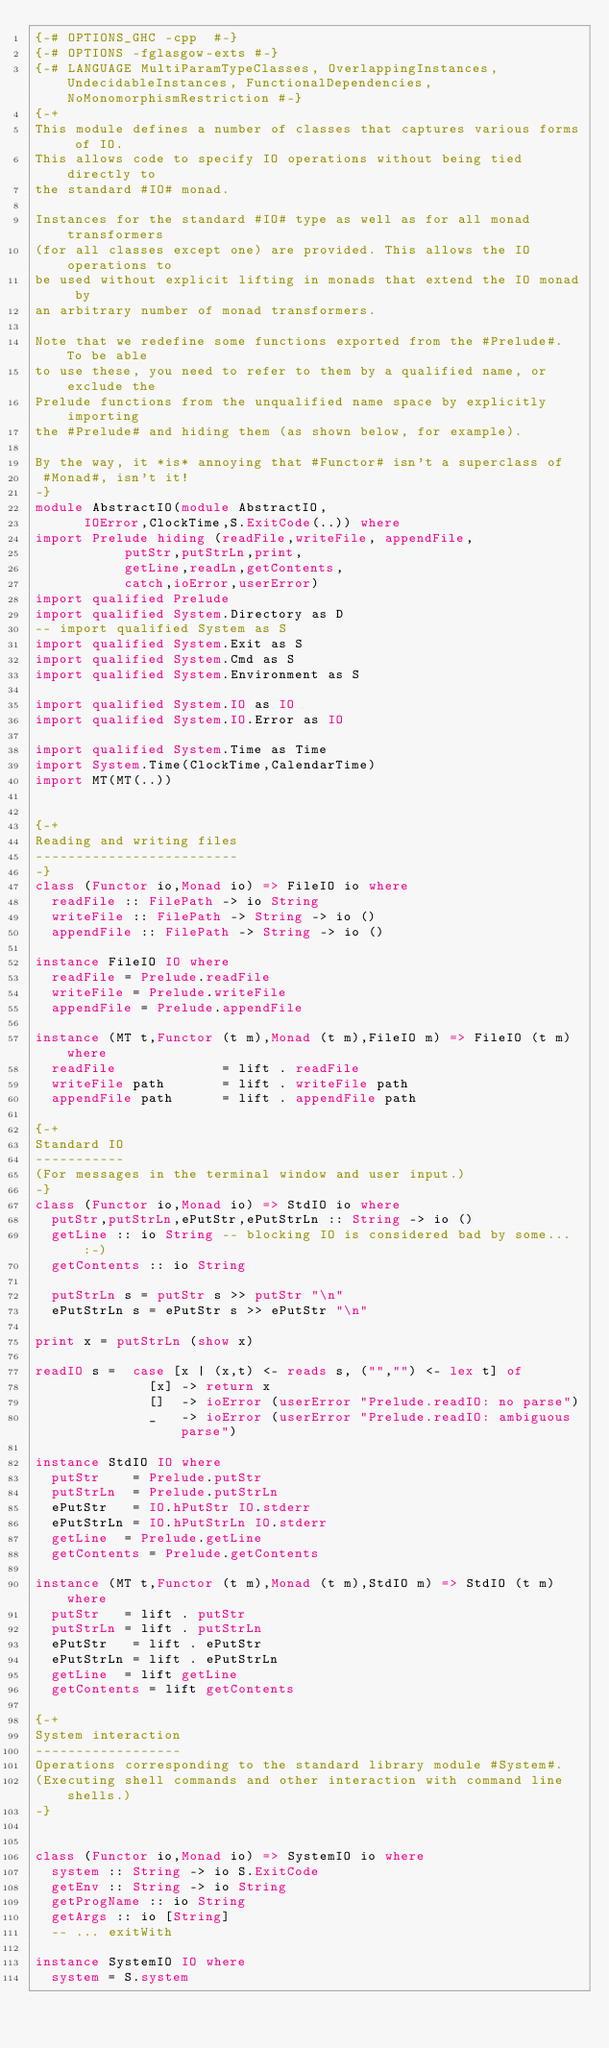<code> <loc_0><loc_0><loc_500><loc_500><_Haskell_>{-# OPTIONS_GHC -cpp  #-}
{-# OPTIONS -fglasgow-exts #-}
{-# LANGUAGE MultiParamTypeClasses, OverlappingInstances, UndecidableInstances, FunctionalDependencies, NoMonomorphismRestriction #-}
{-+
This module defines a number of classes that captures various forms of IO.
This allows code to specify IO operations without being tied directly to
the standard #IO# monad.

Instances for the standard #IO# type as well as for all monad transformers
(for all classes except one) are provided. This allows the IO operations to
be used without explicit lifting in monads that extend the IO monad by
an arbitrary number of monad transformers.

Note that we redefine some functions exported from the #Prelude#. To be able
to use these, you need to refer to them by a qualified name, or exclude the
Prelude functions from the unqualified name space by explicitly importing
the #Prelude# and hiding them (as shown below, for example).

By the way, it *is* annoying that #Functor# isn't a superclass of
 #Monad#, isn't it!
-}
module AbstractIO(module AbstractIO,
		  IOError,ClockTime,S.ExitCode(..)) where
import Prelude hiding (readFile,writeFile, appendFile,
		       putStr,putStrLn,print,
		       getLine,readLn,getContents,
		       catch,ioError,userError)
import qualified Prelude
import qualified System.Directory as D
-- import qualified System as S
import qualified System.Exit as S
import qualified System.Cmd as S
import qualified System.Environment as S

import qualified System.IO as IO
import qualified System.IO.Error as IO

import qualified System.Time as Time
import System.Time(ClockTime,CalendarTime)
import MT(MT(..))


{-+
Reading and writing files
-------------------------
-}
class (Functor io,Monad io) => FileIO io where
  readFile :: FilePath -> io String
  writeFile :: FilePath -> String -> io ()
  appendFile :: FilePath -> String -> io ()

instance FileIO IO where
  readFile = Prelude.readFile
  writeFile = Prelude.writeFile
  appendFile = Prelude.appendFile

instance (MT t,Functor (t m),Monad (t m),FileIO m) => FileIO (t m) where
  readFile             = lift . readFile
  writeFile path       = lift . writeFile path
  appendFile path      = lift . appendFile path

{-+
Standard IO
-----------
(For messages in the terminal window and user input.)
-}
class (Functor io,Monad io) => StdIO io where
  putStr,putStrLn,ePutStr,ePutStrLn :: String -> io ()
  getLine :: io String -- blocking IO is considered bad by some... :-)
  getContents :: io String

  putStrLn s = putStr s >> putStr "\n"
  ePutStrLn s = ePutStr s >> ePutStr "\n"

print x = putStrLn (show x)

readIO s =  case [x | (x,t) <- reads s, ("","") <- lex t] of
              [x] -> return x
              []  -> ioError (userError "Prelude.readIO: no parse")
              _   -> ioError (userError "Prelude.readIO: ambiguous parse")

instance StdIO IO where
  putStr    = Prelude.putStr
  putStrLn  = Prelude.putStrLn
  ePutStr   = IO.hPutStr IO.stderr
  ePutStrLn = IO.hPutStrLn IO.stderr
  getLine  = Prelude.getLine
  getContents = Prelude.getContents

instance (MT t,Functor (t m),Monad (t m),StdIO m) => StdIO (t m) where
  putStr   = lift . putStr
  putStrLn = lift . putStrLn
  ePutStr   = lift . ePutStr
  ePutStrLn = lift . ePutStrLn
  getLine  = lift getLine
  getContents = lift getContents

{-+
System interaction
------------------
Operations corresponding to the standard library module #System#.
(Executing shell commands and other interaction with command line shells.)
-}


class (Functor io,Monad io) => SystemIO io where
  system :: String -> io S.ExitCode
  getEnv :: String -> io String
  getProgName :: io String
  getArgs :: io [String]
  -- ... exitWith

instance SystemIO IO where
  system = S.system</code> 